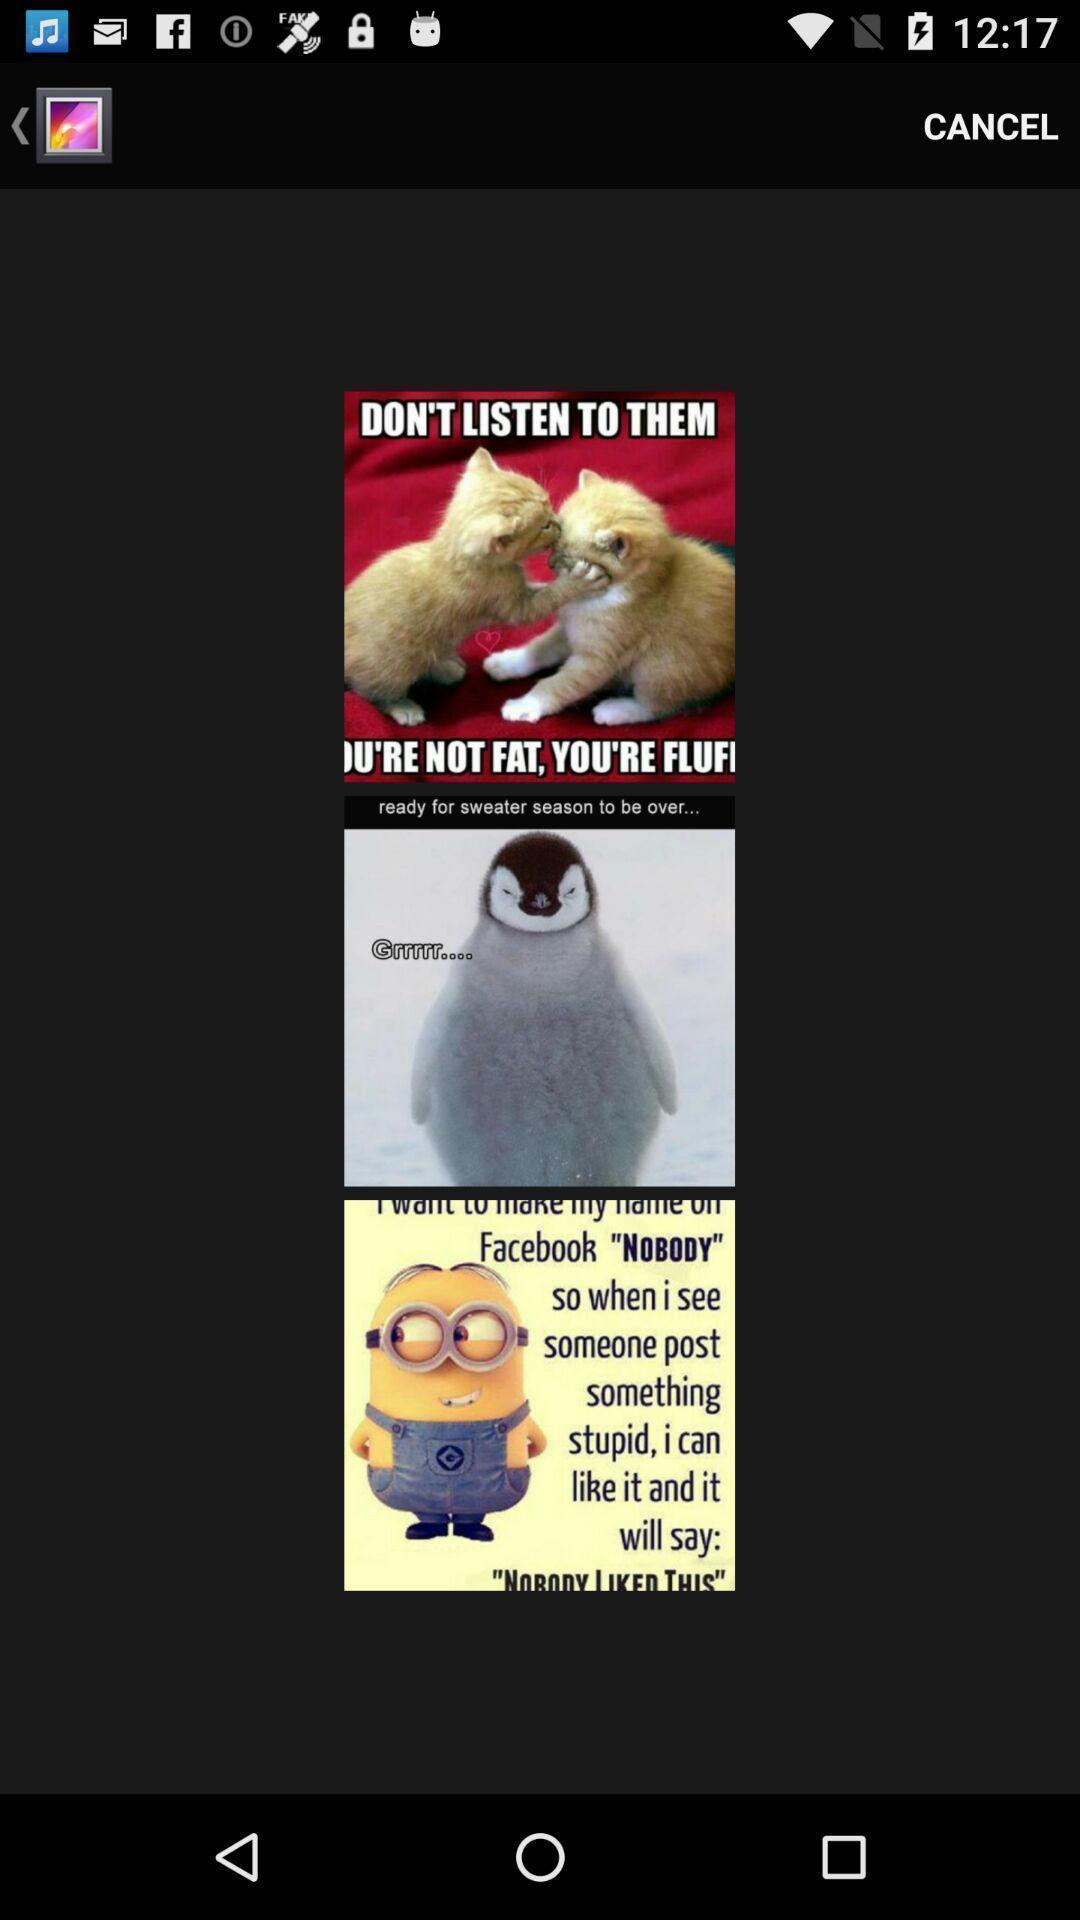Summarize the information in this screenshot. Page showing different images on an app. 